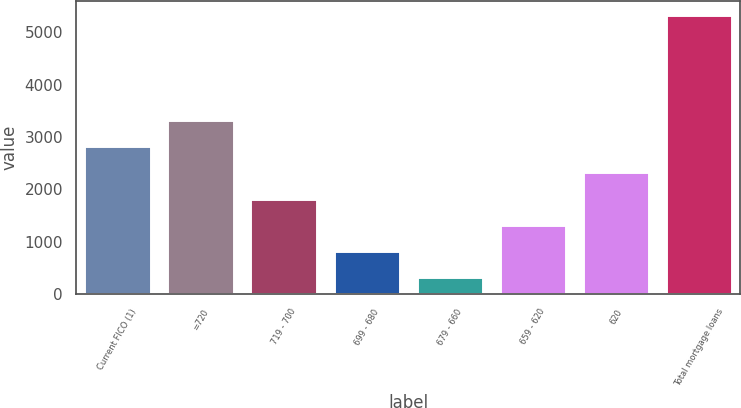Convert chart to OTSL. <chart><loc_0><loc_0><loc_500><loc_500><bar_chart><fcel>Current FICO (1)<fcel>=720<fcel>719 - 700<fcel>699 - 680<fcel>679 - 660<fcel>659 - 620<fcel>620<fcel>Total mortgage loans<nl><fcel>2827.25<fcel>3327.54<fcel>1826.67<fcel>826.09<fcel>325.8<fcel>1326.38<fcel>2326.96<fcel>5328.7<nl></chart> 